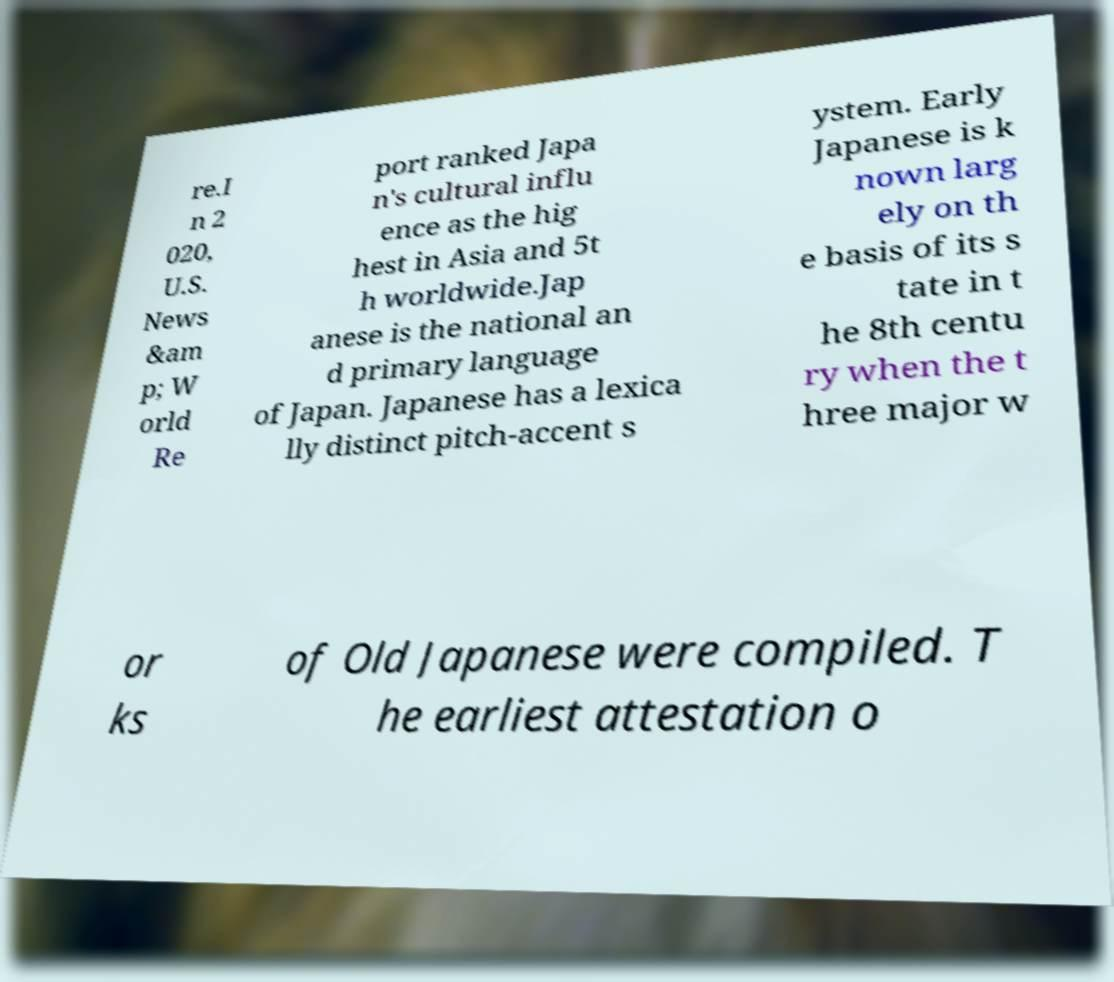Please read and relay the text visible in this image. What does it say? re.I n 2 020, U.S. News &am p; W orld Re port ranked Japa n's cultural influ ence as the hig hest in Asia and 5t h worldwide.Jap anese is the national an d primary language of Japan. Japanese has a lexica lly distinct pitch-accent s ystem. Early Japanese is k nown larg ely on th e basis of its s tate in t he 8th centu ry when the t hree major w or ks of Old Japanese were compiled. T he earliest attestation o 